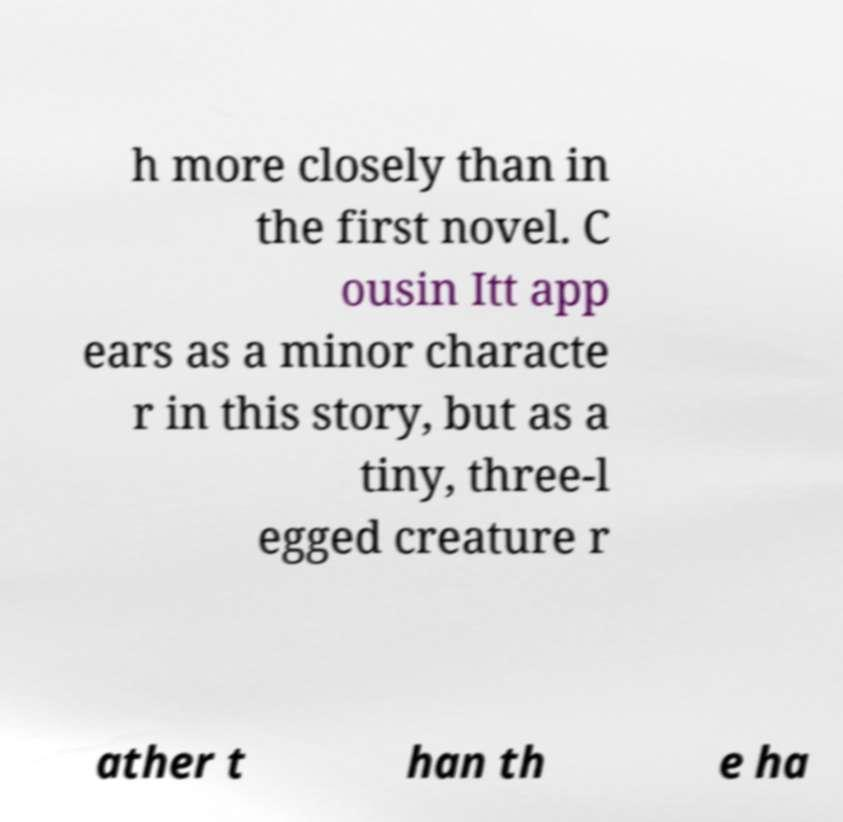What messages or text are displayed in this image? I need them in a readable, typed format. h more closely than in the first novel. C ousin Itt app ears as a minor characte r in this story, but as a tiny, three-l egged creature r ather t han th e ha 